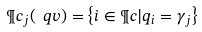<formula> <loc_0><loc_0><loc_500><loc_500>\P c _ { j } ( \ q v ) = \left \{ i \in \P c | q _ { i } = \gamma _ { j } \right \}</formula> 